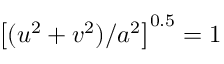<formula> <loc_0><loc_0><loc_500><loc_500>\left [ ( u ^ { 2 } + v ^ { 2 } ) / a ^ { 2 } \right ] ^ { 0 . 5 } = 1</formula> 